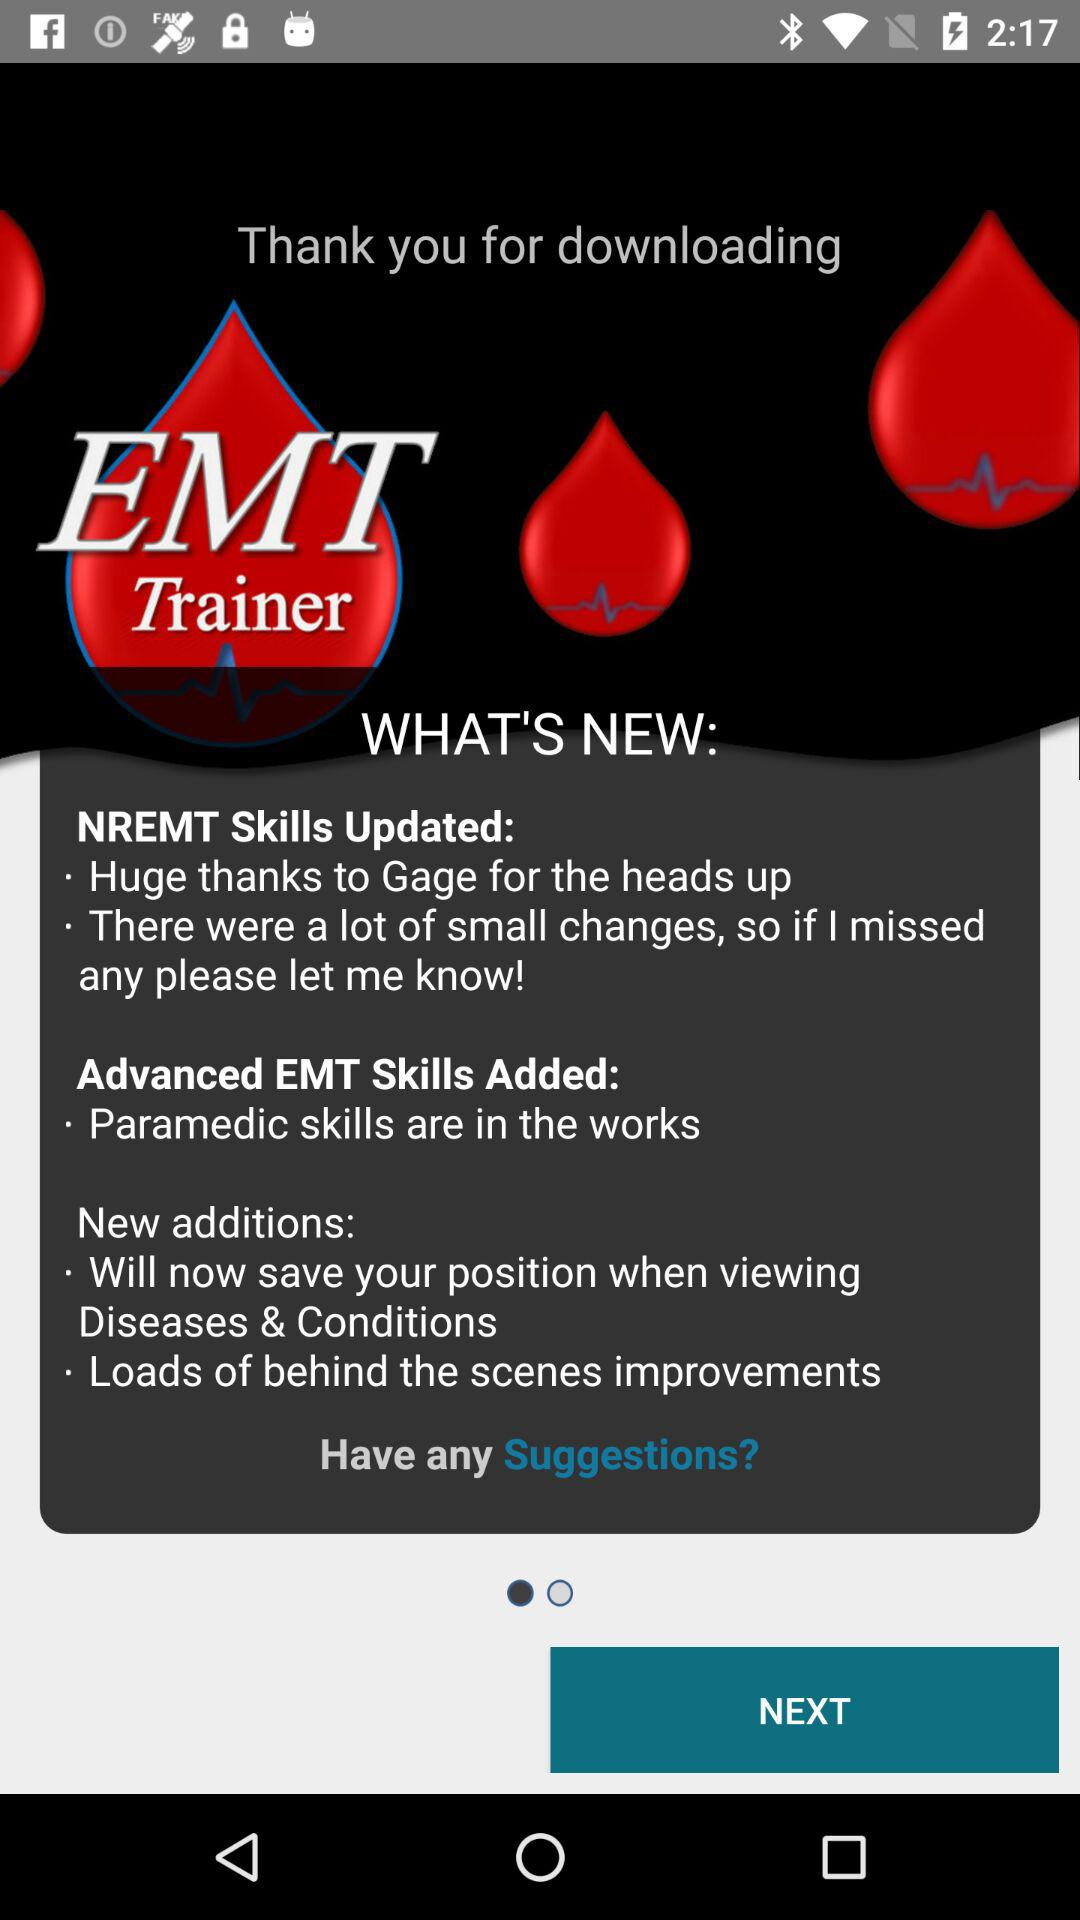What is the first NREMT updated skill? The first updated skill is "Huge thanks to Gage for the heads up". 